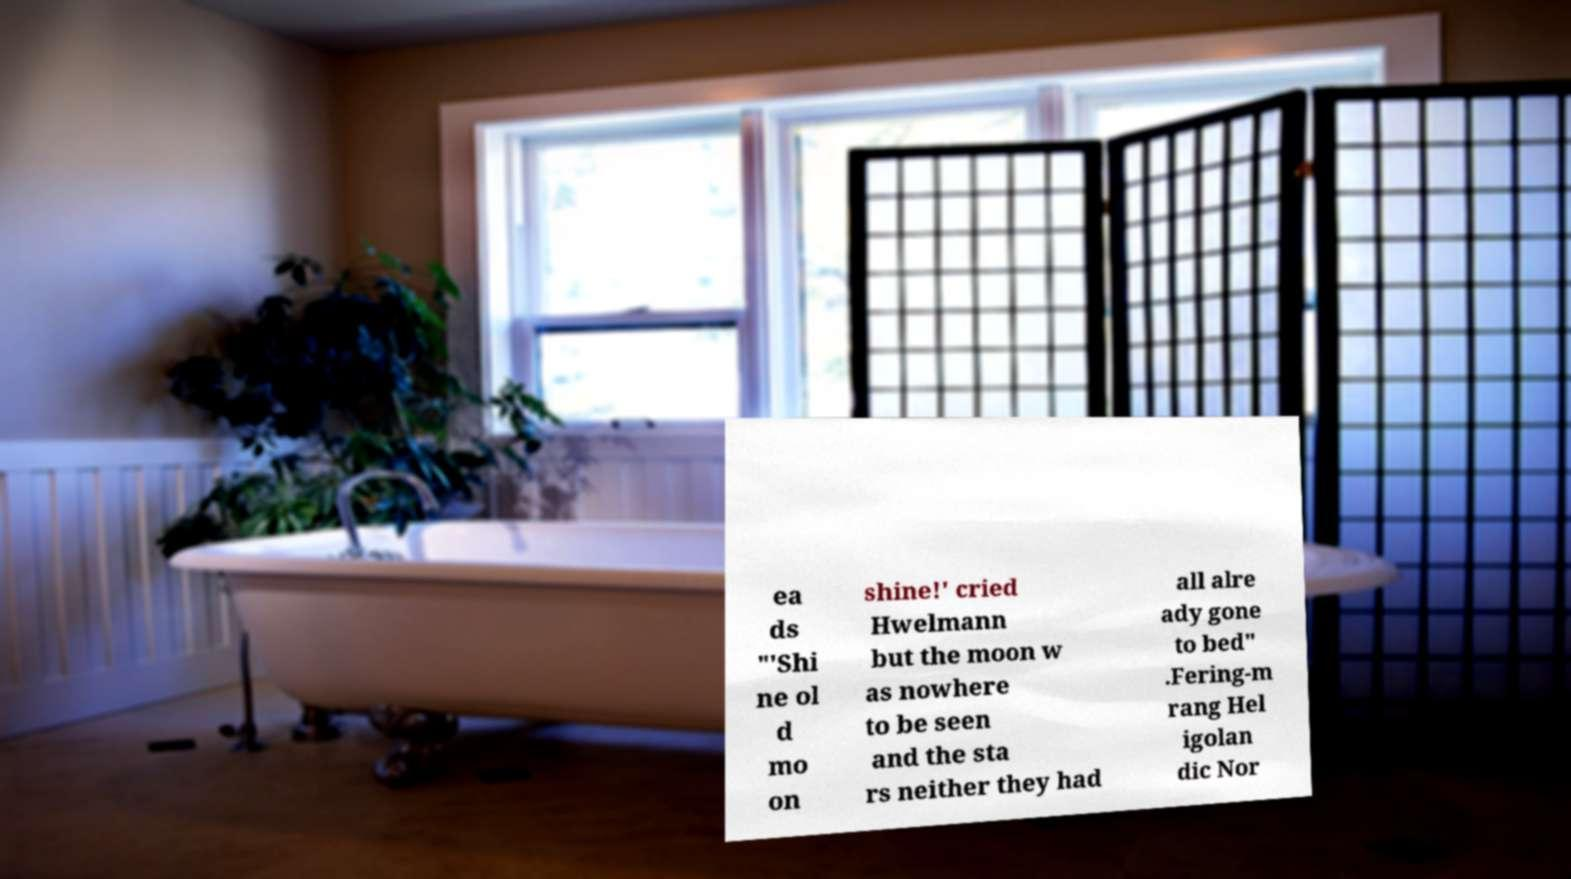For documentation purposes, I need the text within this image transcribed. Could you provide that? ea ds "'Shi ne ol d mo on shine!' cried Hwelmann but the moon w as nowhere to be seen and the sta rs neither they had all alre ady gone to bed" .Fering-m rang Hel igolan dic Nor 